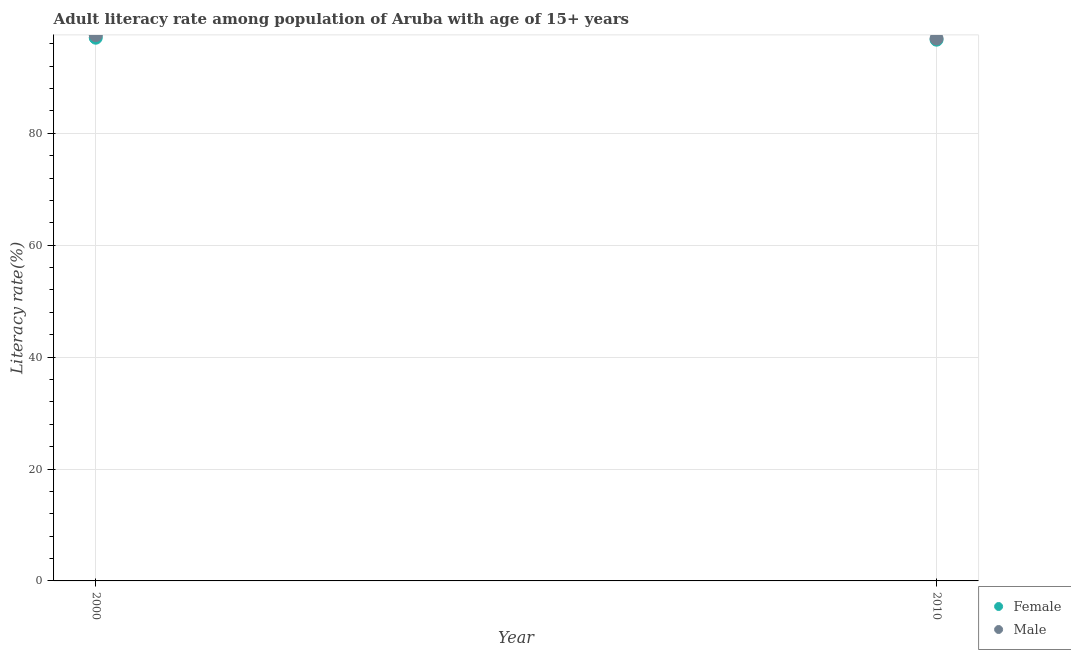What is the female adult literacy rate in 2000?
Your response must be concise. 97.07. Across all years, what is the maximum male adult literacy rate?
Provide a succinct answer. 97.54. Across all years, what is the minimum female adult literacy rate?
Provide a succinct answer. 96.72. In which year was the male adult literacy rate maximum?
Make the answer very short. 2000. In which year was the male adult literacy rate minimum?
Your answer should be very brief. 2010. What is the total female adult literacy rate in the graph?
Offer a very short reply. 193.79. What is the difference between the female adult literacy rate in 2000 and that in 2010?
Keep it short and to the point. 0.35. What is the difference between the male adult literacy rate in 2010 and the female adult literacy rate in 2000?
Provide a short and direct response. -0.13. What is the average female adult literacy rate per year?
Ensure brevity in your answer.  96.9. In the year 2000, what is the difference between the male adult literacy rate and female adult literacy rate?
Provide a succinct answer. 0.47. What is the ratio of the male adult literacy rate in 2000 to that in 2010?
Your answer should be very brief. 1.01. Is the female adult literacy rate in 2000 less than that in 2010?
Offer a terse response. No. In how many years, is the male adult literacy rate greater than the average male adult literacy rate taken over all years?
Make the answer very short. 1. Does the male adult literacy rate monotonically increase over the years?
Make the answer very short. No. Is the female adult literacy rate strictly greater than the male adult literacy rate over the years?
Offer a very short reply. No. Is the male adult literacy rate strictly less than the female adult literacy rate over the years?
Offer a terse response. No. What is the difference between two consecutive major ticks on the Y-axis?
Your answer should be compact. 20. Are the values on the major ticks of Y-axis written in scientific E-notation?
Give a very brief answer. No. Does the graph contain any zero values?
Ensure brevity in your answer.  No. How many legend labels are there?
Your answer should be compact. 2. What is the title of the graph?
Your response must be concise. Adult literacy rate among population of Aruba with age of 15+ years. What is the label or title of the X-axis?
Make the answer very short. Year. What is the label or title of the Y-axis?
Offer a very short reply. Literacy rate(%). What is the Literacy rate(%) of Female in 2000?
Provide a short and direct response. 97.07. What is the Literacy rate(%) in Male in 2000?
Give a very brief answer. 97.54. What is the Literacy rate(%) of Female in 2010?
Your answer should be very brief. 96.72. What is the Literacy rate(%) in Male in 2010?
Provide a short and direct response. 96.94. Across all years, what is the maximum Literacy rate(%) in Female?
Provide a short and direct response. 97.07. Across all years, what is the maximum Literacy rate(%) in Male?
Provide a short and direct response. 97.54. Across all years, what is the minimum Literacy rate(%) of Female?
Your answer should be very brief. 96.72. Across all years, what is the minimum Literacy rate(%) in Male?
Provide a short and direct response. 96.94. What is the total Literacy rate(%) in Female in the graph?
Your response must be concise. 193.79. What is the total Literacy rate(%) of Male in the graph?
Give a very brief answer. 194.48. What is the difference between the Literacy rate(%) in Female in 2000 and that in 2010?
Give a very brief answer. 0.35. What is the difference between the Literacy rate(%) in Male in 2000 and that in 2010?
Offer a terse response. 0.6. What is the difference between the Literacy rate(%) in Female in 2000 and the Literacy rate(%) in Male in 2010?
Ensure brevity in your answer.  0.13. What is the average Literacy rate(%) in Female per year?
Provide a short and direct response. 96.9. What is the average Literacy rate(%) of Male per year?
Give a very brief answer. 97.24. In the year 2000, what is the difference between the Literacy rate(%) in Female and Literacy rate(%) in Male?
Your response must be concise. -0.47. In the year 2010, what is the difference between the Literacy rate(%) of Female and Literacy rate(%) of Male?
Your answer should be compact. -0.22. What is the difference between the highest and the second highest Literacy rate(%) in Female?
Offer a terse response. 0.35. What is the difference between the highest and the second highest Literacy rate(%) of Male?
Keep it short and to the point. 0.6. What is the difference between the highest and the lowest Literacy rate(%) of Female?
Offer a very short reply. 0.35. What is the difference between the highest and the lowest Literacy rate(%) of Male?
Your answer should be compact. 0.6. 